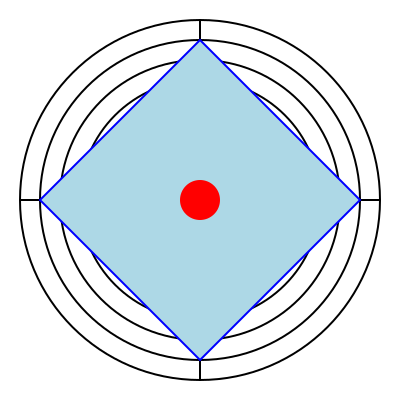In the context of anti-doping efforts in sports, consider the logo above as a potential symbol for a clean sports initiative. How many times can this logo be rotated around its center to produce an identical image? To determine the number of rotational symmetries, we need to analyze the logo's components and their arrangement:

1. The logo consists of concentric circles, which have infinite rotational symmetry.
2. The blue diamond shape has four-fold rotational symmetry (90°, 180°, 270°, and 360°).
3. The red circle in the center has infinite rotational symmetry.
4. The crucial element limiting the rotational symmetry is the cross formed by the two perpendicular lines.

The cross divides the logo into four equal quadrants. This means the logo will look identical after rotations of:

1. 90° (quarter turn)
2. 180° (half turn)
3. 270° (three-quarter turn)
4. 360° (full turn, back to the original position)

Therefore, the logo has 4 rotational symmetries, including the original position.

This design choice symbolizes fairness and equality in sports, aligning with the philanthropist's mission to support clean sports initiatives. The four-fold symmetry could represent the four cardinal virtues of sports ethics: fairness, respect, equality, and integrity.
Answer: 4 